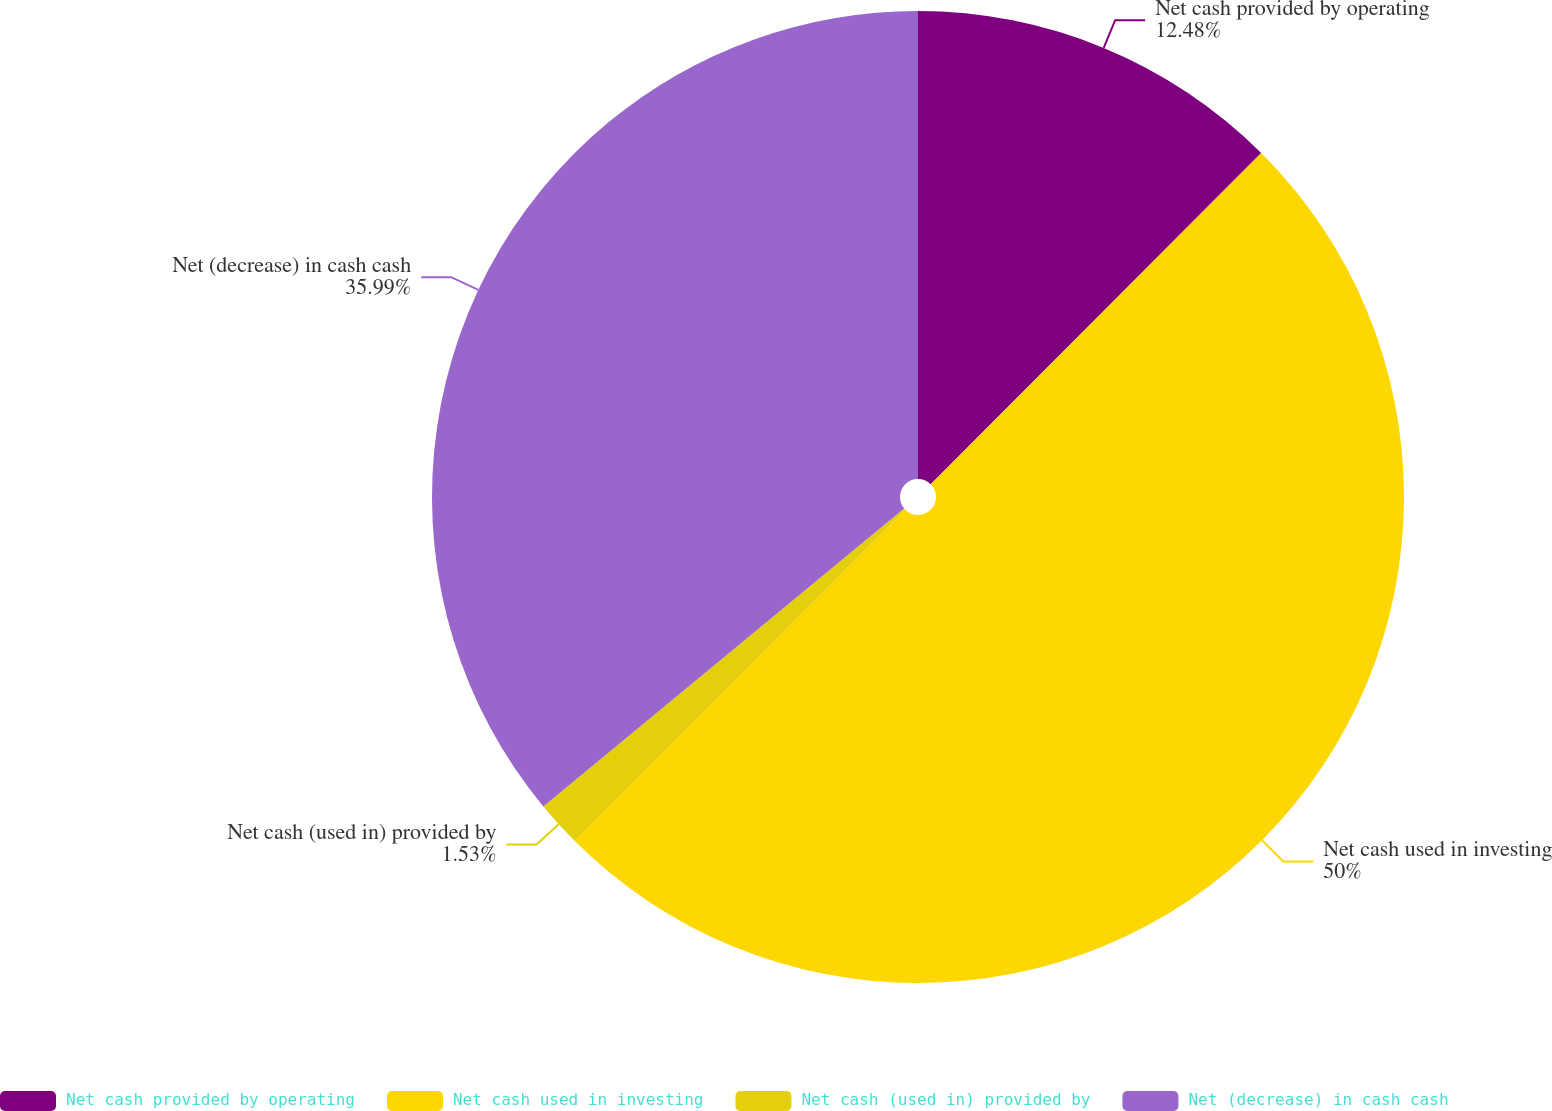<chart> <loc_0><loc_0><loc_500><loc_500><pie_chart><fcel>Net cash provided by operating<fcel>Net cash used in investing<fcel>Net cash (used in) provided by<fcel>Net (decrease) in cash cash<nl><fcel>12.48%<fcel>50.0%<fcel>1.53%<fcel>35.99%<nl></chart> 